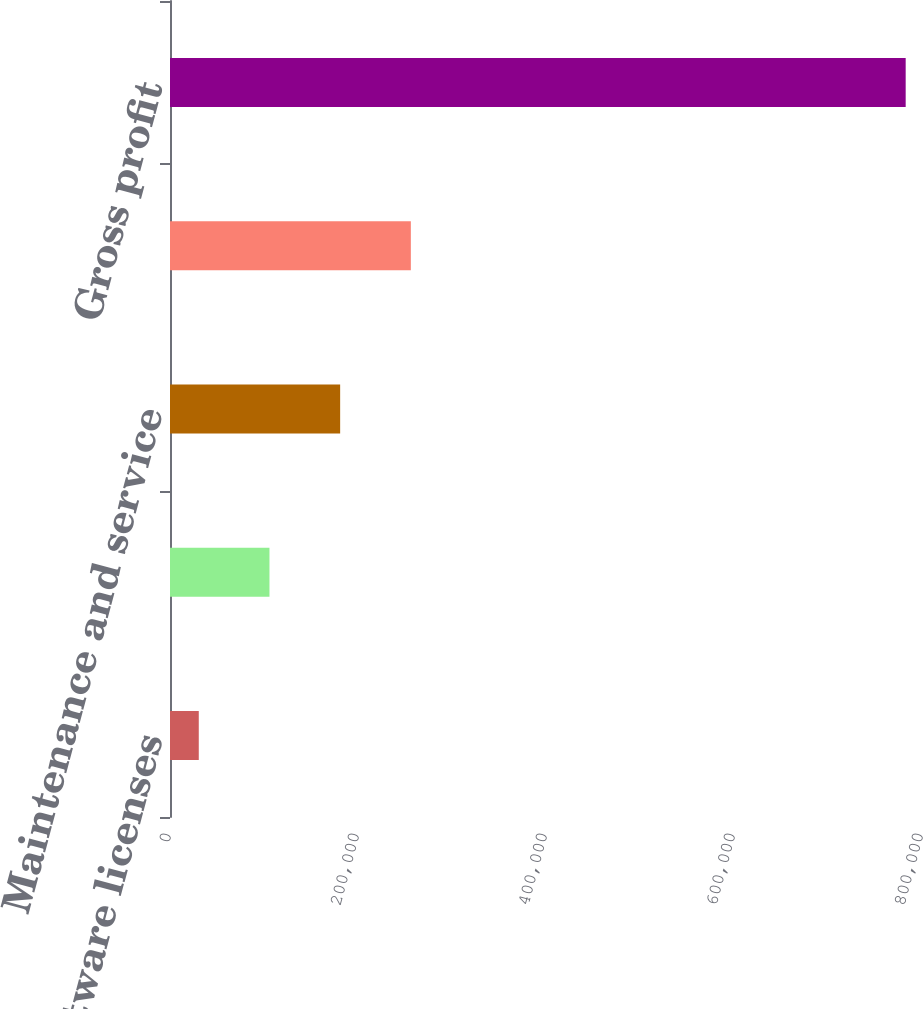Convert chart to OTSL. <chart><loc_0><loc_0><loc_500><loc_500><bar_chart><fcel>Software licenses<fcel>Amortization<fcel>Maintenance and service<fcel>Total cost of sales<fcel>Gross profit<nl><fcel>30607<fcel>105810<fcel>181013<fcel>256215<fcel>782635<nl></chart> 